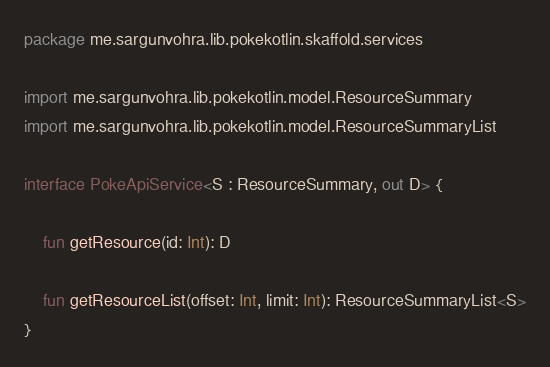Convert code to text. <code><loc_0><loc_0><loc_500><loc_500><_Kotlin_>package me.sargunvohra.lib.pokekotlin.skaffold.services

import me.sargunvohra.lib.pokekotlin.model.ResourceSummary
import me.sargunvohra.lib.pokekotlin.model.ResourceSummaryList

interface PokeApiService<S : ResourceSummary, out D> {

    fun getResource(id: Int): D

    fun getResourceList(offset: Int, limit: Int): ResourceSummaryList<S>
}</code> 